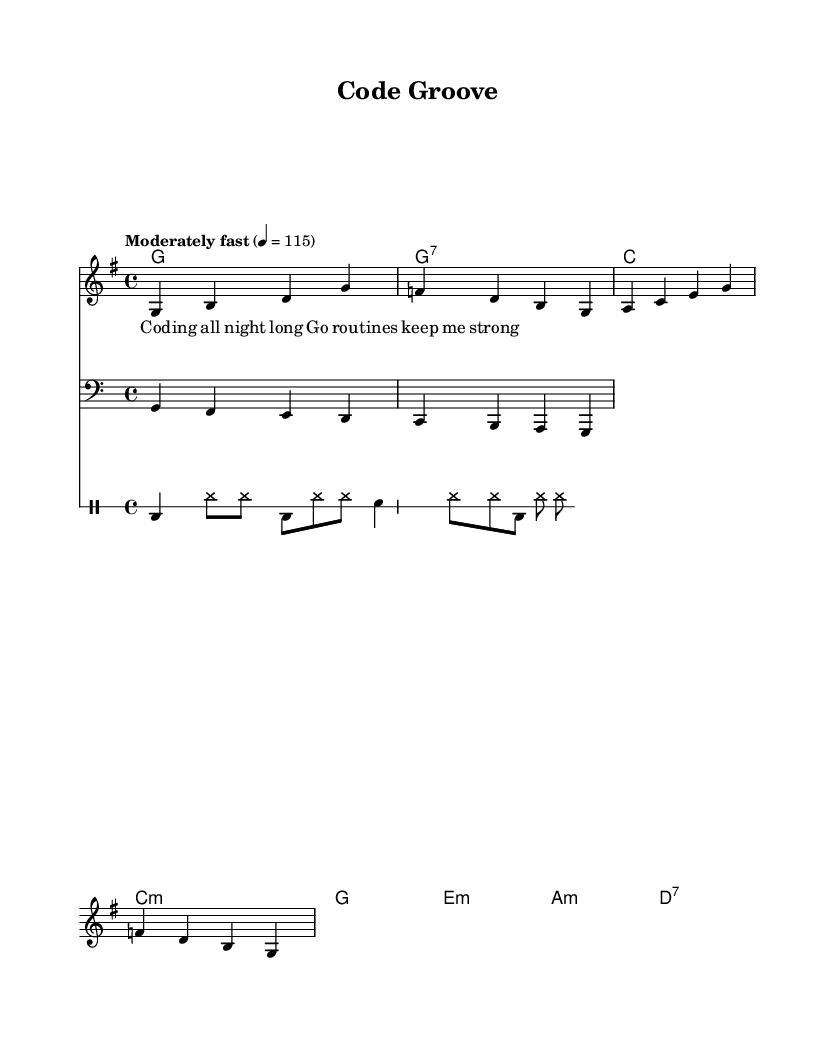What is the key signature of this music? The key signature is G major, which has one sharp (F#). This can be identified in the global section of the provided code where the command `\key g \major` is used.
Answer: G major What is the time signature of this music? The time signature is 4/4, which means there are four beats in a measure and the quarter note gets one beat. This is indicated in the global section of the code with the command `\time 4/4`.
Answer: 4/4 What is the tempo of this piece? The tempo is indicated as "Moderately fast" with a metronome marking of 115 beats per minute. This can be found in the global section of the code where the command `\tempo "Moderately fast" 4 = 115` is specified.
Answer: 115 What chord is played on the first measure? The first measure contains a G major chord, which is placed within the chord mode section of the code. The chord notation `g1` specifies this chord at the beginning.
Answer: G major What is the primary theme of the lyrics? The lyrics emphasize the notion of coding and the strength of routines, as seen in the text section of the code. The lines focus on coding "all night long" and routines keeping one "strong," indicating a motivational theme for productivity during coding sessions.
Answer: Coding all night long What kind of drum pattern is used? The drum pattern includes bass drum and snare sounds with hi-hat accents, shown in the drummode section of the code. It alternates between bass (bd), snare (sn), and hi-hat (hh), creating a typical energetic groove for soul music.
Answer: Energetic groove 